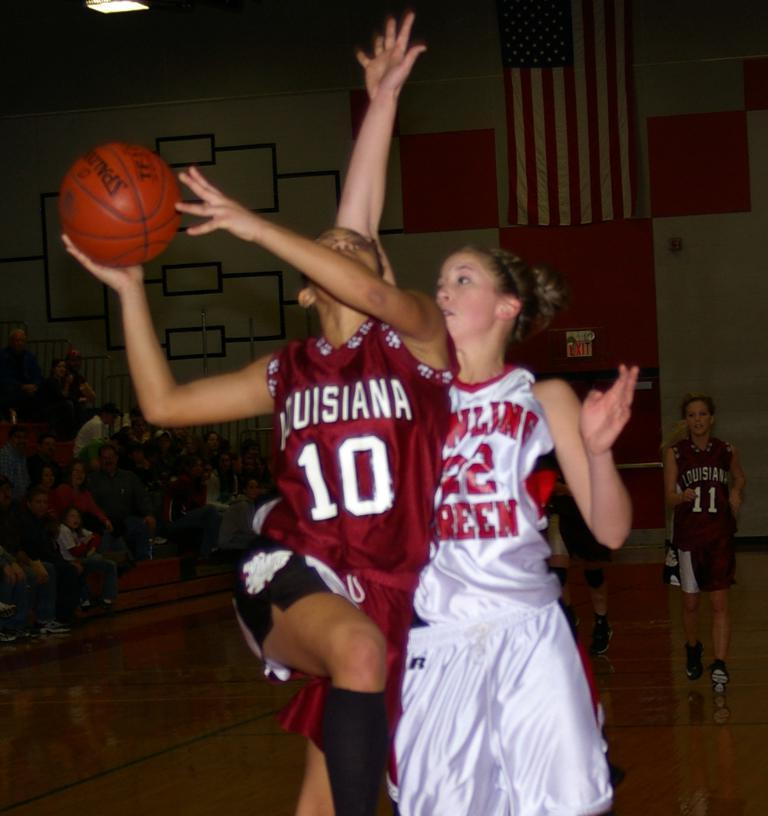<image>
Share a concise interpretation of the image provided. Number 22 tries to block the Louisiana Number 10 player. 